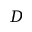Convert formula to latex. <formula><loc_0><loc_0><loc_500><loc_500>D</formula> 